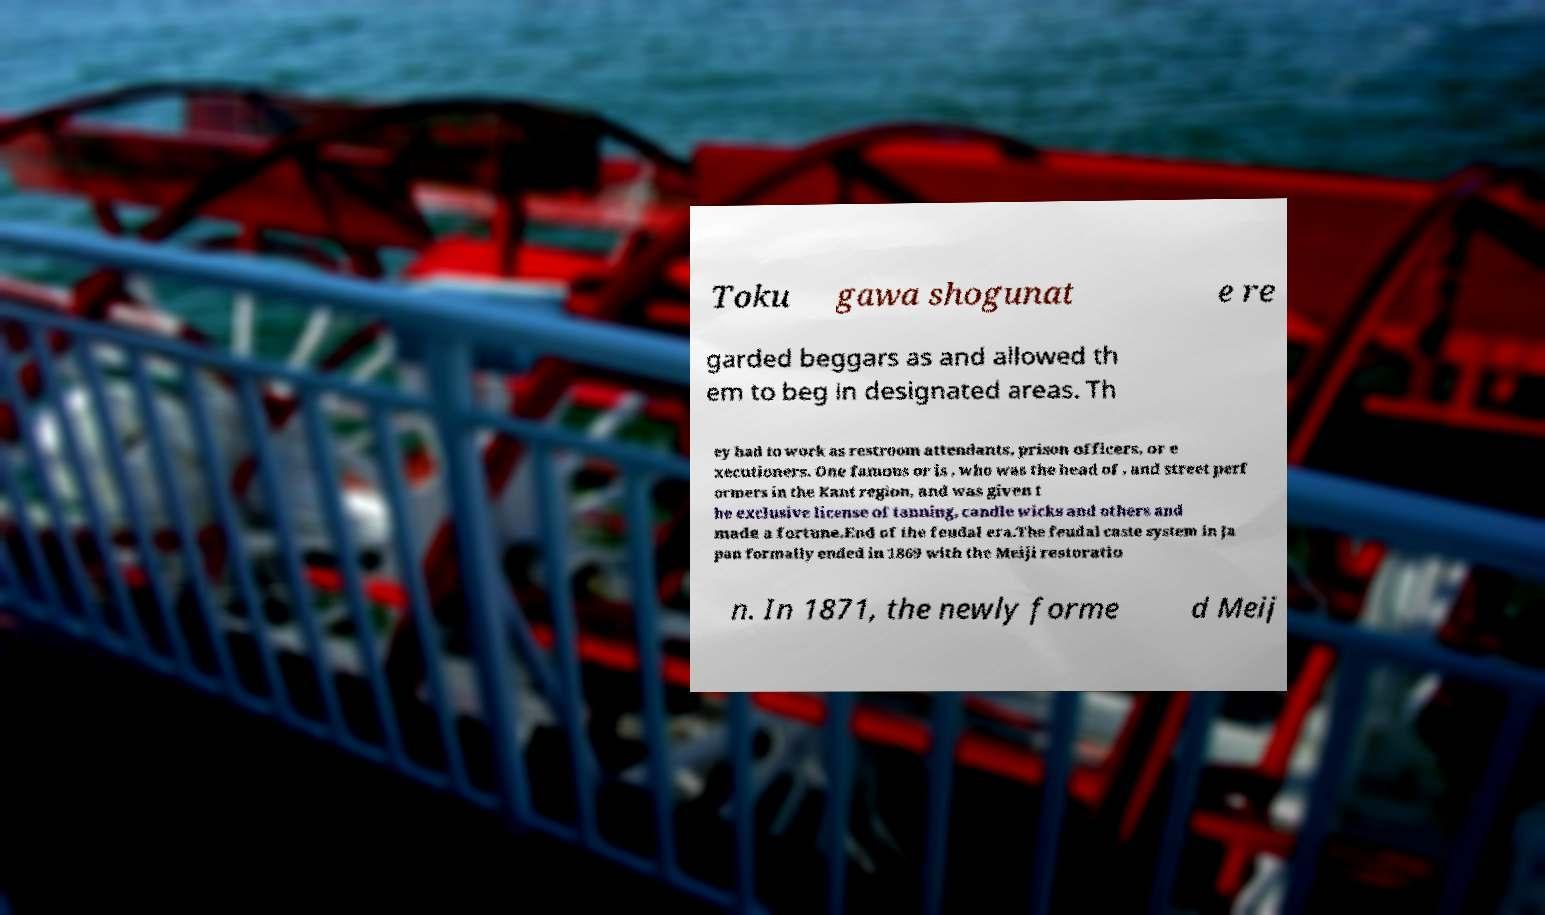Please read and relay the text visible in this image. What does it say? Toku gawa shogunat e re garded beggars as and allowed th em to beg in designated areas. Th ey had to work as restroom attendants, prison officers, or e xecutioners. One famous or is , who was the head of , and street perf ormers in the Kant region, and was given t he exclusive license of tanning, candle wicks and others and made a fortune.End of the feudal era.The feudal caste system in Ja pan formally ended in 1869 with the Meiji restoratio n. In 1871, the newly forme d Meij 